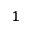Convert formula to latex. <formula><loc_0><loc_0><loc_500><loc_500>^ { 1 }</formula> 